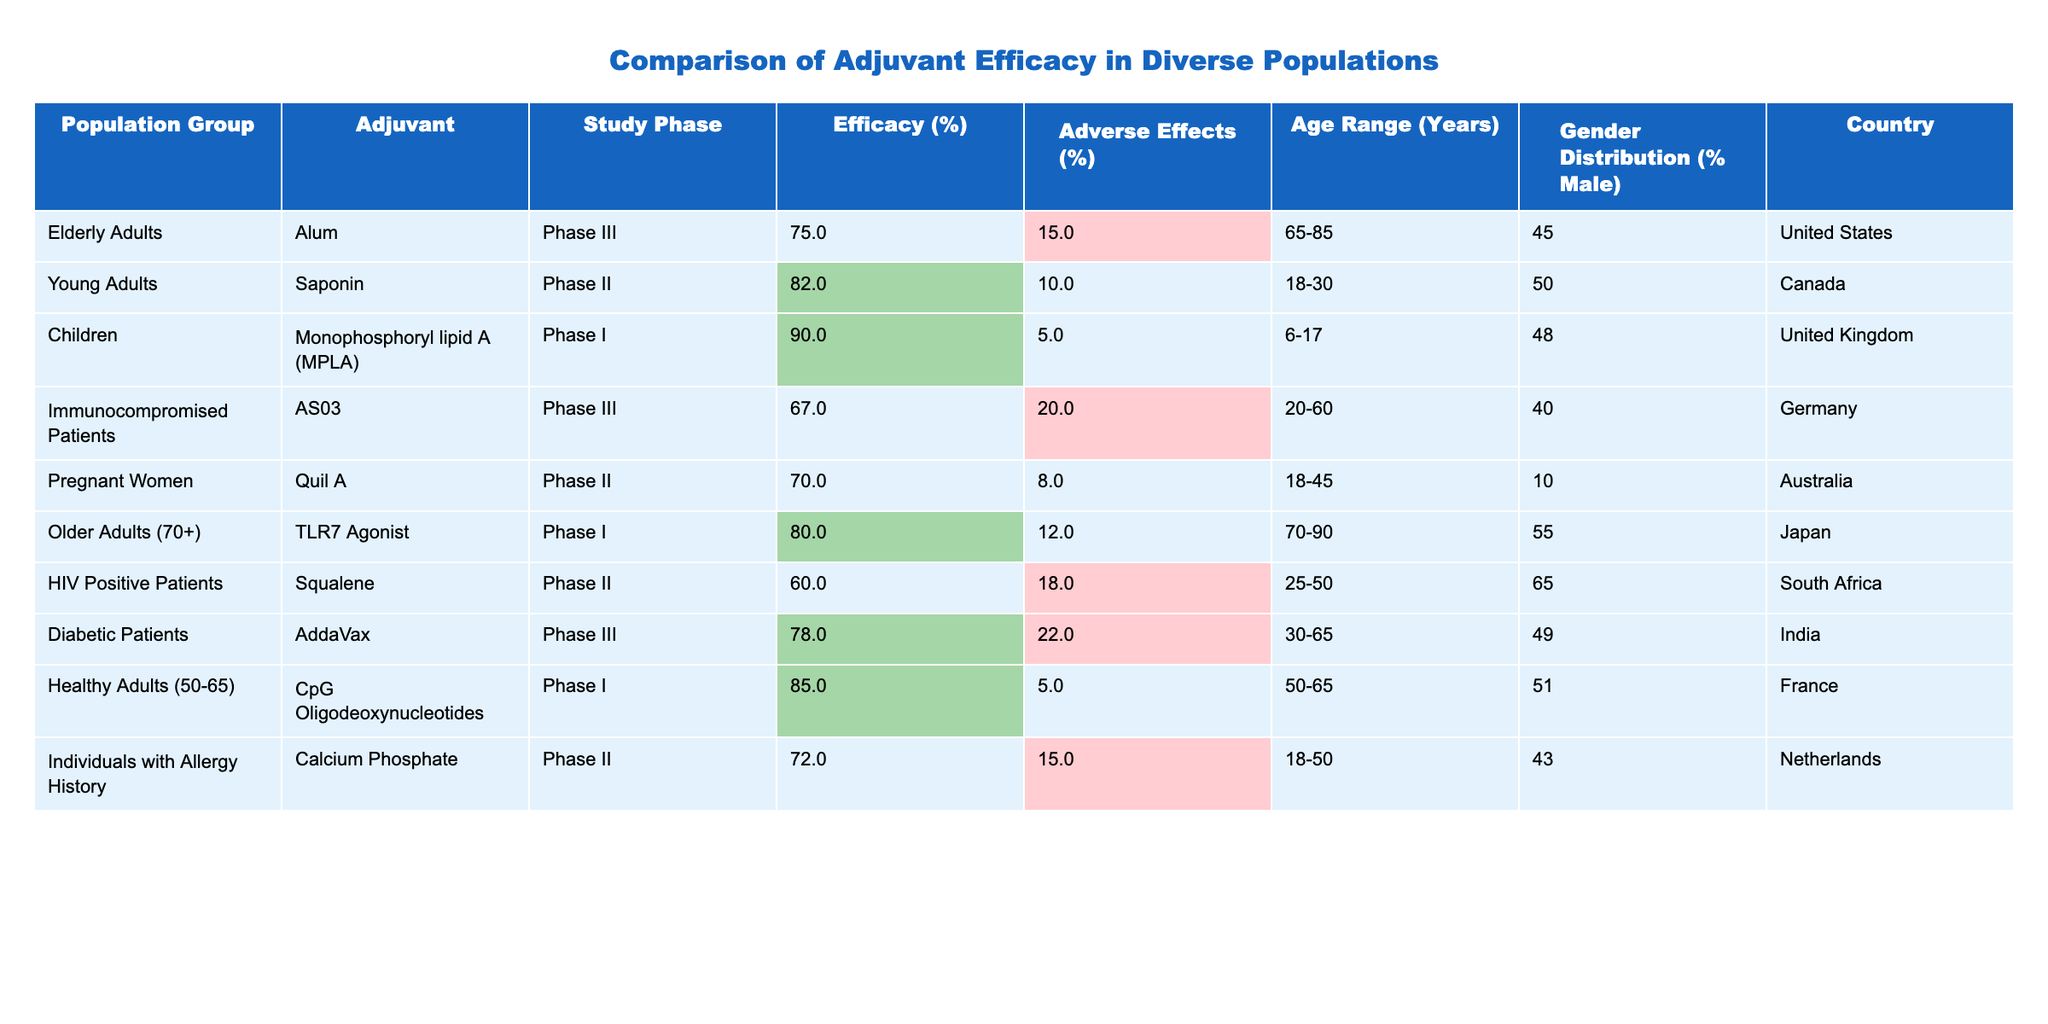What is the efficacy percentage of the adjuvant used in Children? According to the table, the efficacy percentage for the adjuvant Monophosphoryl lipid A (MPLA) in Children is listed as 90%.
Answer: 90% Which population group experienced the highest adverse effects percentage? The table shows that the HIV Positive Patients with the Squalene adjuvant experienced the highest adverse effects percentage at 18%.
Answer: 18% What is the average efficacy of all the adjuvants listed? To find the average efficacy, add up all the efficacy percentages: 75 + 82 + 90 + 67 + 70 + 80 + 60 + 78 + 85 + 72 =  79.7, then divide by the number of groups (10). Thus, the average efficacy is 797/10 = 79.7%.
Answer: 79.7% Is there any population group where the efficacy exceeds 85%? The efficacy percentage for Children (90%) and Healthy Adults (85%) both exceed 85%, confirming that there are indeed groups with efficacies above this threshold.
Answer: Yes How does the adverse effects percentage of Immunocompromised Patients compare to that of Diabetic Patients? Immunocompromised Patients have an adverse effects percentage of 20%, while Diabetic Patients have 22%, indicating that Diabetic Patients experience a slightly higher percentage of adverse effects.
Answer: Diabetic Patients experience a higher percentage Which adjuvant has the lowest efficacy and what is the percentage? The adjuvant with the lowest efficacy is Squalene used in HIV Positive Patients, with an efficacy percentage of 60%.
Answer: Squalene, 60% Are there any gender distributions where the percentage of males exceeds 50%? The table shows that the gender distribution percentage of males exceeds 50% in two groups: Older Adults (70+) at 55% and HIV Positive Patients at 65%.
Answer: Yes What is the difference in efficacy between the best-performing and worst-performing adjuvant groups? The best-performing adjuvant group is Children with 90% efficacy, while the worst-performing is HIV Positive Patients with 60%. The difference in efficacy is 90% - 60% = 30%.
Answer: 30% In which country were the elderly adults studied, and what was their efficacy rate? The table indicates that elderly adults were studied in the United States, and their efficacy rate with the adjuvant Alum was 75%.
Answer: United States, 75% Calculate the average age range of the population groups involved in the study. To find the average, consider the midpoint for each age range: Elderly Adults (75), Young Adults (24), Children (12.5), Immunocompromised Patients (40), Pregnant Women (31.5), Older Adults (80), HIV Positive Patients (37.5), Diabetic Patients (47.5), Healthy Adults (57.5), and Individuals with Allergy History (34). Summing these midpoints gives a total of 376.5, and dividing by 10 gives an average of 37.65.
Answer: 37.65 